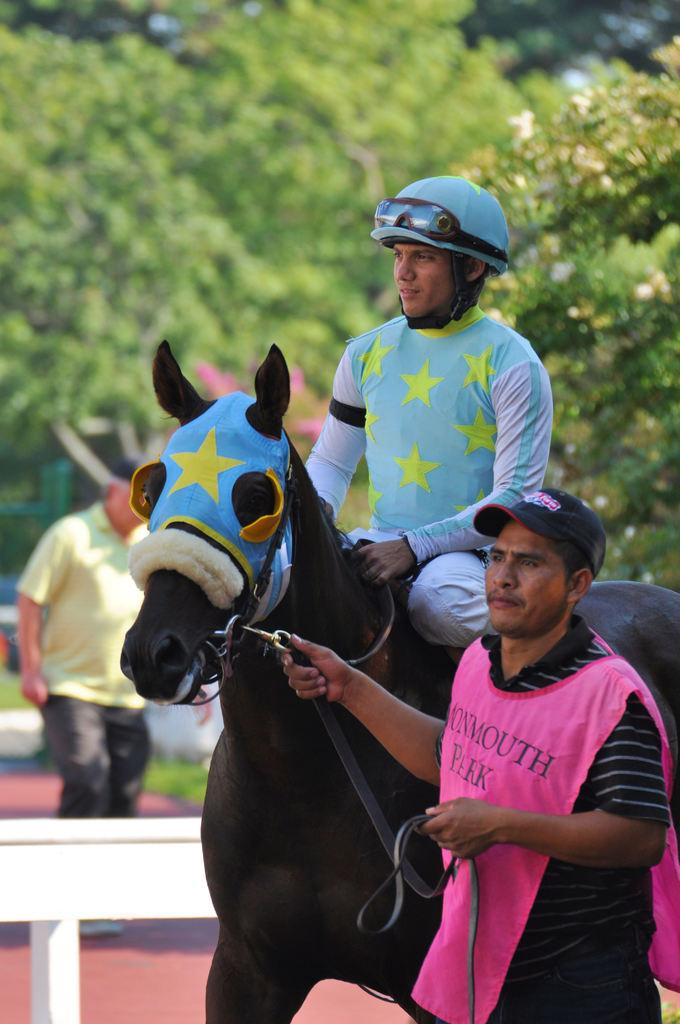What is the man in the foreground of the image doing? The man in the foreground is standing and holding a horse. What is the man in the middle of the image doing? The man in the middle is sitting and riding the horse. Can you describe the man in the background? The man in the background is standing. What can be seen in the background of the image? Trees are visible in the background. How many parcels can be seen falling from the sky in the image? There are no parcels visible in the image, nor are any falling from the sky. 